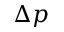Convert formula to latex. <formula><loc_0><loc_0><loc_500><loc_500>\Delta p</formula> 